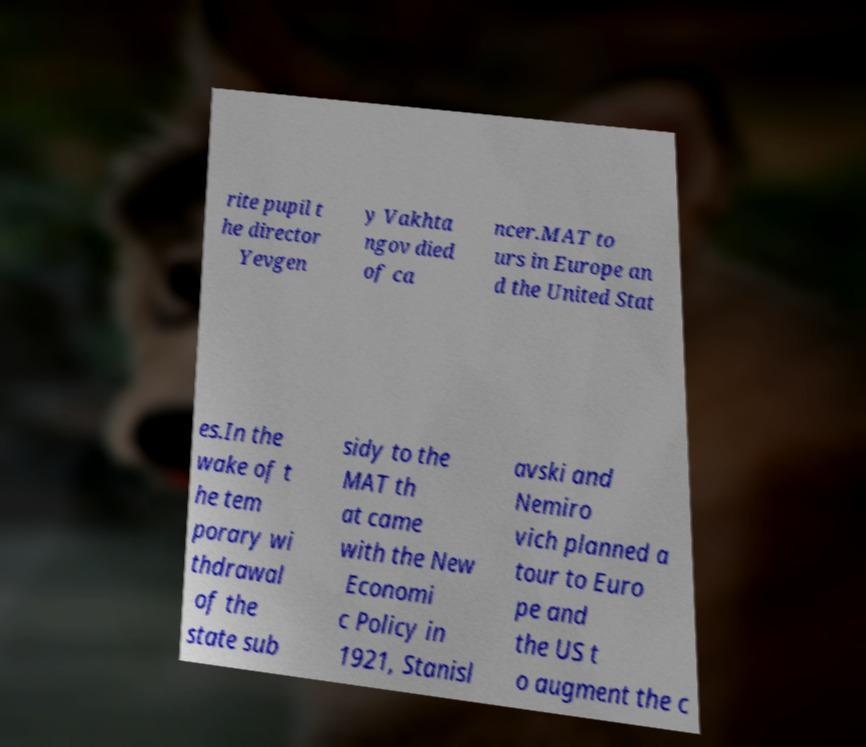Could you extract and type out the text from this image? rite pupil t he director Yevgen y Vakhta ngov died of ca ncer.MAT to urs in Europe an d the United Stat es.In the wake of t he tem porary wi thdrawal of the state sub sidy to the MAT th at came with the New Economi c Policy in 1921, Stanisl avski and Nemiro vich planned a tour to Euro pe and the US t o augment the c 